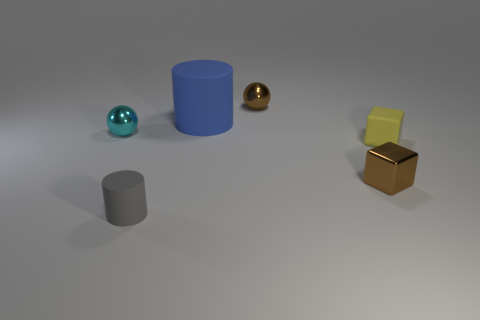How many other things are there of the same material as the cyan sphere?
Your answer should be very brief. 2. How many yellow things are in front of the small object that is behind the tiny cyan shiny thing?
Ensure brevity in your answer.  1. Is the color of the metallic ball on the right side of the gray rubber thing the same as the small metallic block that is right of the large matte cylinder?
Ensure brevity in your answer.  Yes. Are there fewer matte objects than cyan spheres?
Ensure brevity in your answer.  No. There is a small rubber thing behind the brown object in front of the yellow cube; what shape is it?
Give a very brief answer. Cube. Is there any other thing that has the same size as the blue thing?
Your answer should be compact. No. There is a brown object that is on the left side of the brown shiny object in front of the object right of the metallic block; what is its shape?
Ensure brevity in your answer.  Sphere. What number of objects are either shiny spheres that are right of the cyan sphere or small brown objects that are in front of the yellow cube?
Your answer should be very brief. 2. There is a gray thing; is its size the same as the sphere that is behind the large blue object?
Provide a succinct answer. Yes. Is the material of the small brown object in front of the yellow object the same as the small brown object that is behind the small yellow matte object?
Keep it short and to the point. Yes. 